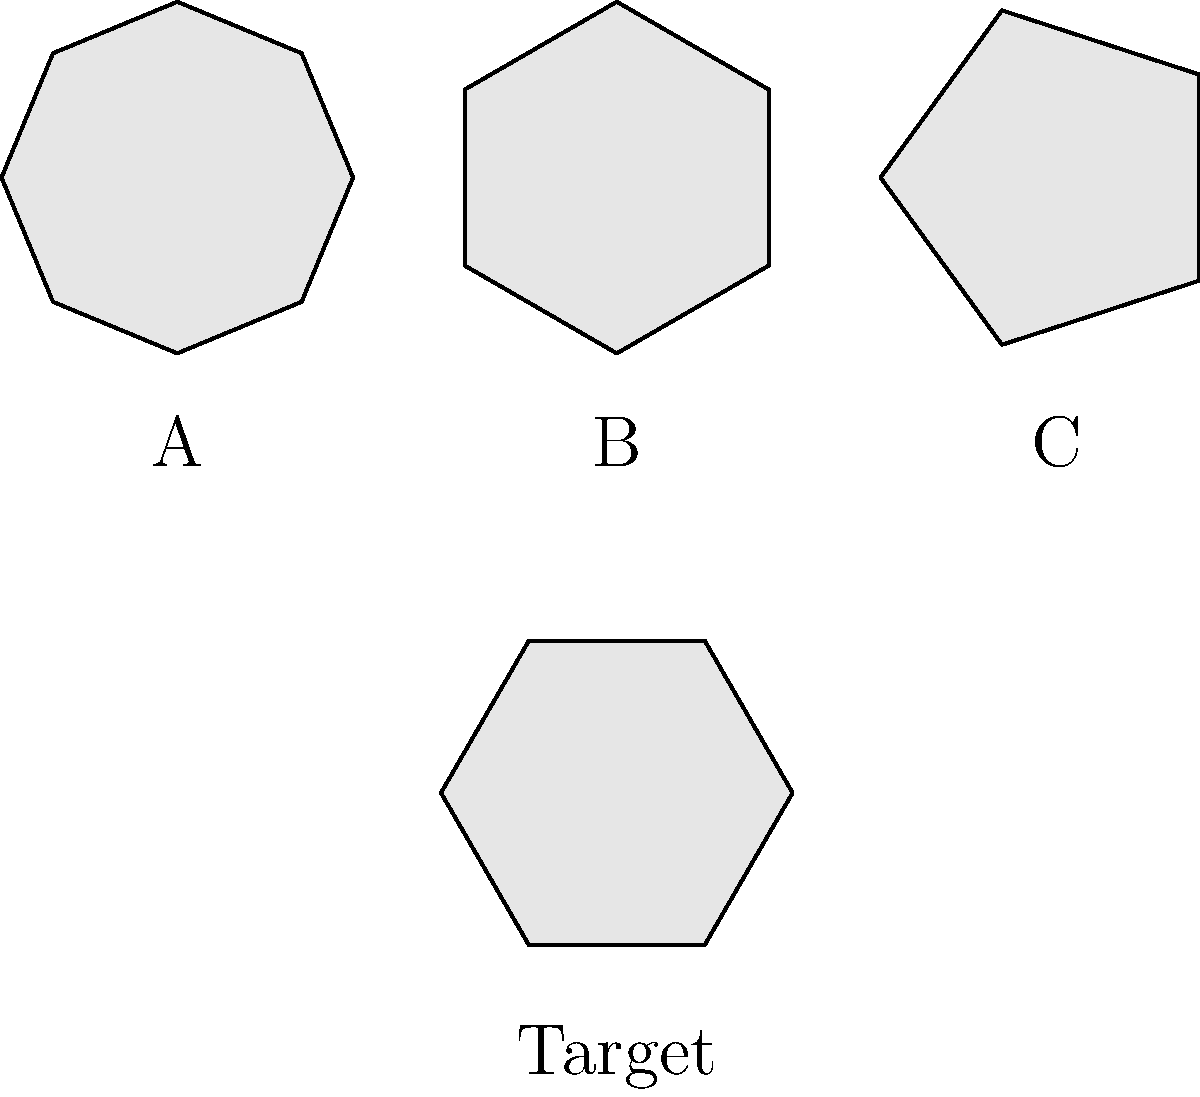As a coin collector, you're examining three unique coins with different shapes and orientations. Coin A is an octagon, Coin B is a hexagon, and Coin C is a pentagon. Which coin needs to be rotated to match the orientation of the target coin shown at the bottom? To solve this problem, we need to mentally rotate each coin and compare it to the target coin:

1. Coin A (Octagon):
   - Has 8 sides, different from the target coin (6 sides).
   - No rotation will make it match the target.

2. Coin B (Hexagon):
   - Has 6 sides, same as the target coin.
   - Currently rotated by $\frac{\pi}{6}$ radians (30 degrees).
   - Needs to be rotated counterclockwise by $\frac{\pi}{6}$ radians to match the target.

3. Coin C (Pentagon):
   - Has 5 sides, different from the target coin (6 sides).
   - No rotation will make it match the target.

Therefore, Coin B is the only coin that can be rotated to match the orientation of the target coin.
Answer: Coin B 